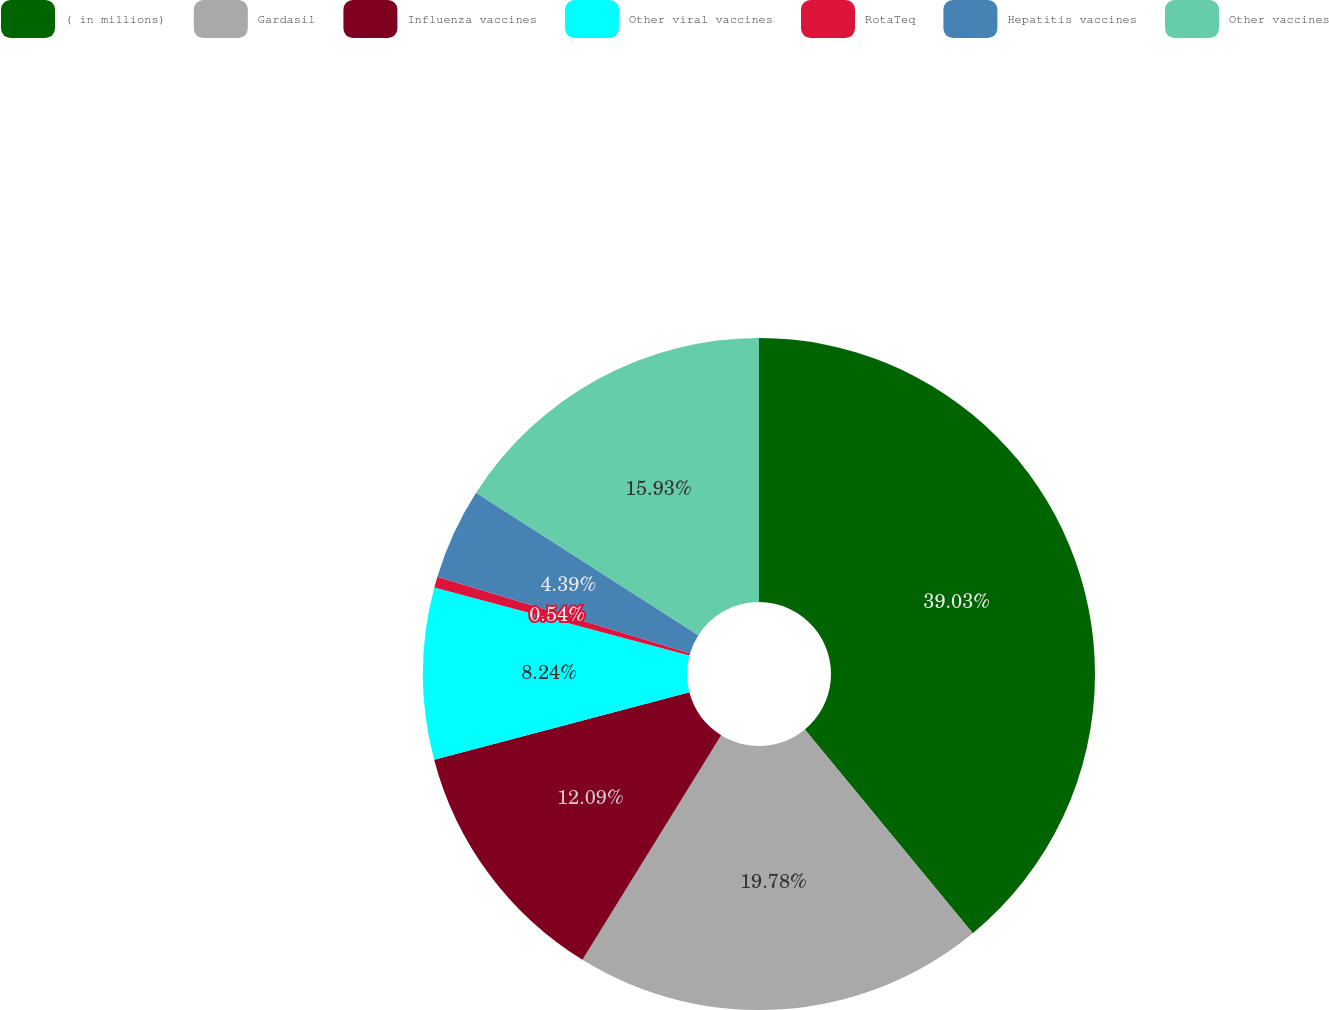Convert chart to OTSL. <chart><loc_0><loc_0><loc_500><loc_500><pie_chart><fcel>( in millions)<fcel>Gardasil<fcel>Influenza vaccines<fcel>Other viral vaccines<fcel>RotaTeq<fcel>Hepatitis vaccines<fcel>Other vaccines<nl><fcel>39.02%<fcel>19.78%<fcel>12.09%<fcel>8.24%<fcel>0.54%<fcel>4.39%<fcel>15.93%<nl></chart> 